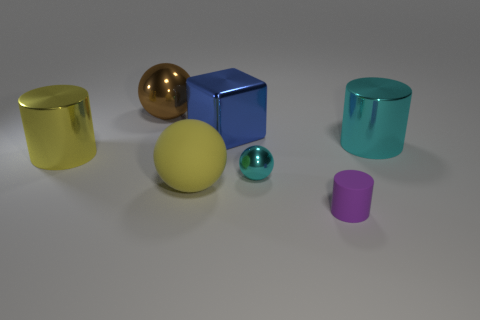Subtract all green spheres. Subtract all brown cylinders. How many spheres are left? 3 Add 2 big cyan cylinders. How many objects exist? 9 Subtract all blocks. How many objects are left? 6 Add 6 big cylinders. How many big cylinders are left? 8 Add 3 blue spheres. How many blue spheres exist? 3 Subtract 0 cyan blocks. How many objects are left? 7 Subtract all tiny blue matte cylinders. Subtract all big yellow things. How many objects are left? 5 